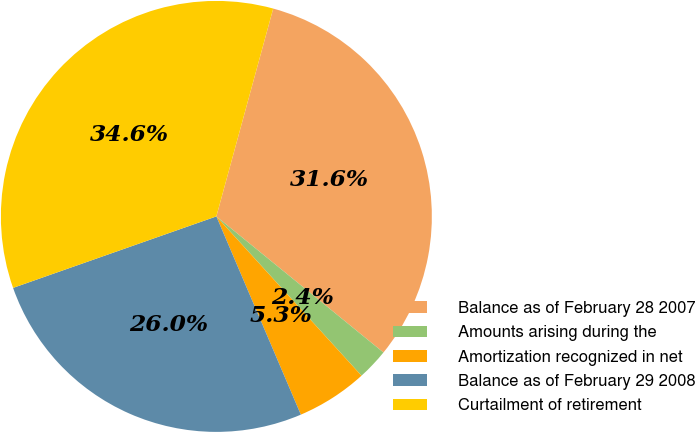Convert chart to OTSL. <chart><loc_0><loc_0><loc_500><loc_500><pie_chart><fcel>Balance as of February 28 2007<fcel>Amounts arising during the<fcel>Amortization recognized in net<fcel>Balance as of February 29 2008<fcel>Curtailment of retirement<nl><fcel>31.63%<fcel>2.36%<fcel>5.35%<fcel>26.03%<fcel>34.63%<nl></chart> 